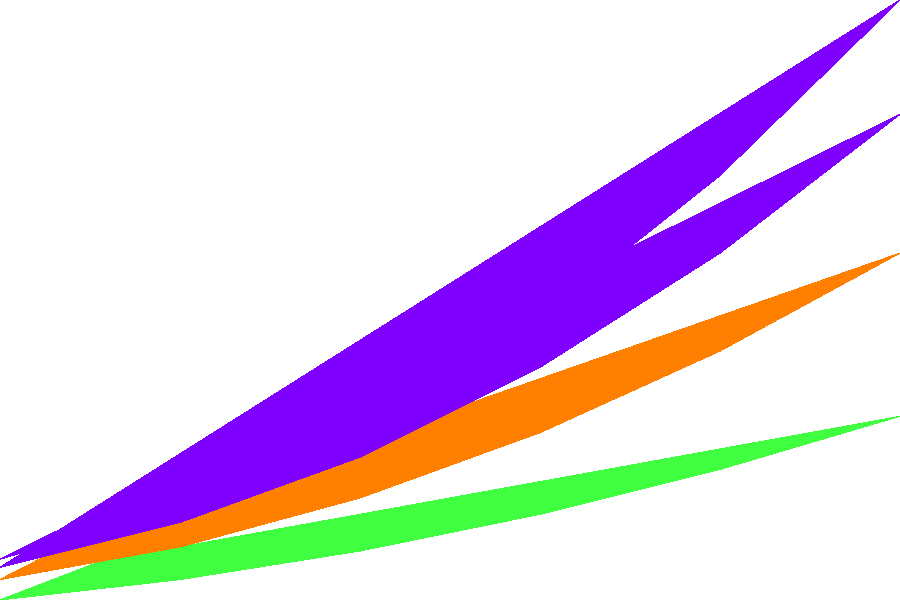Based on the stacked area chart showing the growth of various data-related job roles in Kenya from 2015 to 2020, which role has consistently maintained the largest share of the job market throughout the entire period? To determine which role has consistently maintained the largest share of the job market, we need to analyze the chart layer by layer:

1. The bottom layer (dark blue) represents Data Analysts.
2. The second layer (green) represents Data Scientists.
3. The third layer (orange) represents Data Engineers.
4. The top layer (purple) represents Machine Learning Engineers.

The role with the largest share will be the one with the thickest layer throughout the entire period.

Step-by-step analysis:
1. In 2015 (leftmost part of the chart), the dark blue layer (Data Analysts) is clearly the thickest.
2. As we move right towards 2020, we can observe that the dark blue layer remains the thickest throughout all years.
3. The other layers (Data Scientists, Data Engineers, and Machine Learning Engineers) grow over time but never surpass the thickness of the Data Analyst layer.
4. Even in 2020 (rightmost part of the chart), the Data Analyst layer is still the thickest, indicating it has the largest share of jobs.

Therefore, Data Analysts have consistently maintained the largest share of the data-related job market in Kenya from 2015 to 2020.
Answer: Data Analysts 